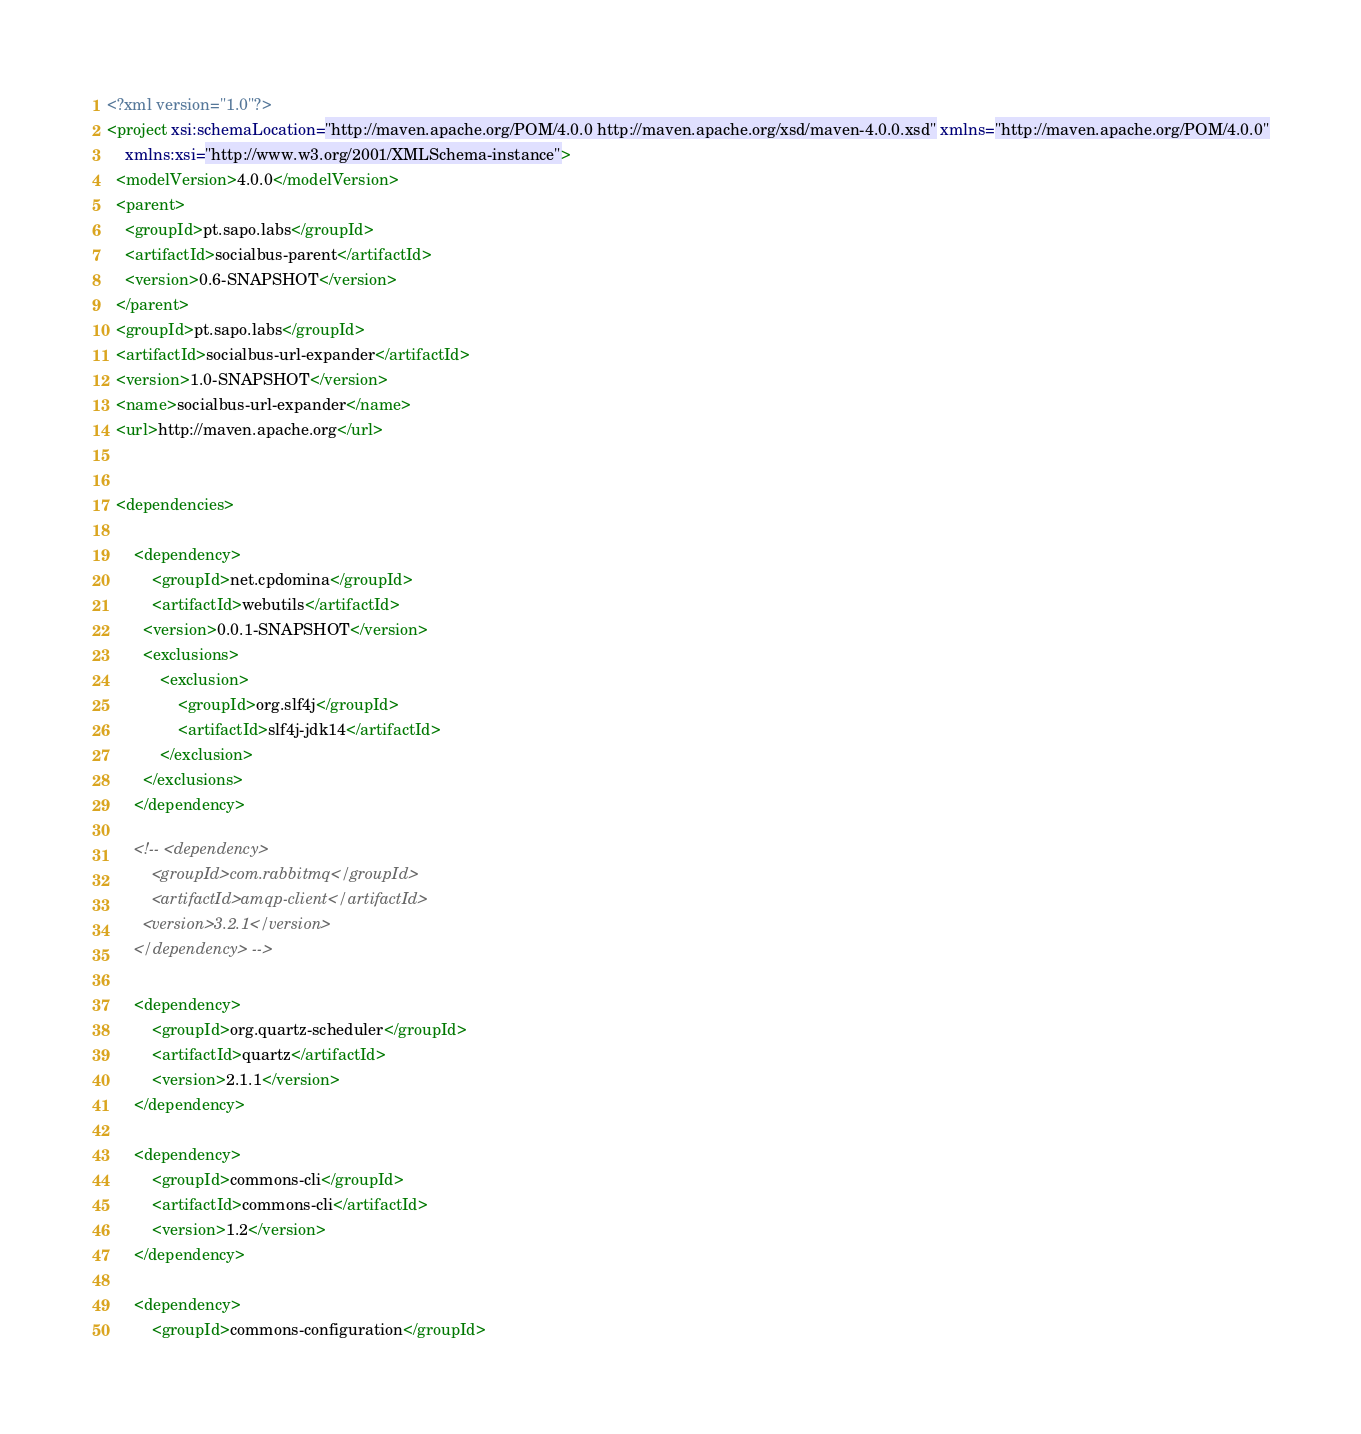<code> <loc_0><loc_0><loc_500><loc_500><_XML_><?xml version="1.0"?>
<project xsi:schemaLocation="http://maven.apache.org/POM/4.0.0 http://maven.apache.org/xsd/maven-4.0.0.xsd" xmlns="http://maven.apache.org/POM/4.0.0"
    xmlns:xsi="http://www.w3.org/2001/XMLSchema-instance">
  <modelVersion>4.0.0</modelVersion>
  <parent>
    <groupId>pt.sapo.labs</groupId>
    <artifactId>socialbus-parent</artifactId>
    <version>0.6-SNAPSHOT</version>
  </parent>
  <groupId>pt.sapo.labs</groupId>
  <artifactId>socialbus-url-expander</artifactId>
  <version>1.0-SNAPSHOT</version>
  <name>socialbus-url-expander</name>
  <url>http://maven.apache.org</url>
  
  
  <dependencies>
	  
	  <dependency>
          <groupId>net.cpdomina</groupId>
          <artifactId>webutils</artifactId>
      	<version>0.0.1-SNAPSHOT</version>
        <exclusions>
            <exclusion>
                <groupId>org.slf4j</groupId>
                <artifactId>slf4j-jdk14</artifactId>
            </exclusion>
        </exclusions>
      </dependency>
	  
	  <!-- <dependency>
          <groupId>com.rabbitmq</groupId>
          <artifactId>amqp-client</artifactId>
		<version>3.2.1</version>
      </dependency> -->
	  
      <dependency>
          <groupId>org.quartz-scheduler</groupId>
          <artifactId>quartz</artifactId>
          <version>2.1.1</version>
      </dependency>

      <dependency>
          <groupId>commons-cli</groupId>
          <artifactId>commons-cli</artifactId>
          <version>1.2</version>
      </dependency>

      <dependency>
          <groupId>commons-configuration</groupId></code> 